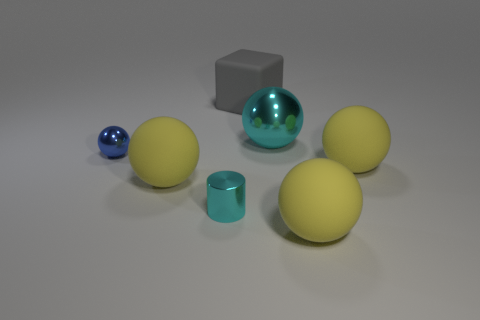What does the lighting in the image suggest about the setting? The lighting in the image is even and diffused, suggesting an indoor setting with controlled lighting conditions, possibly intended to highlight the objects and their features without creating harsh shadows. 